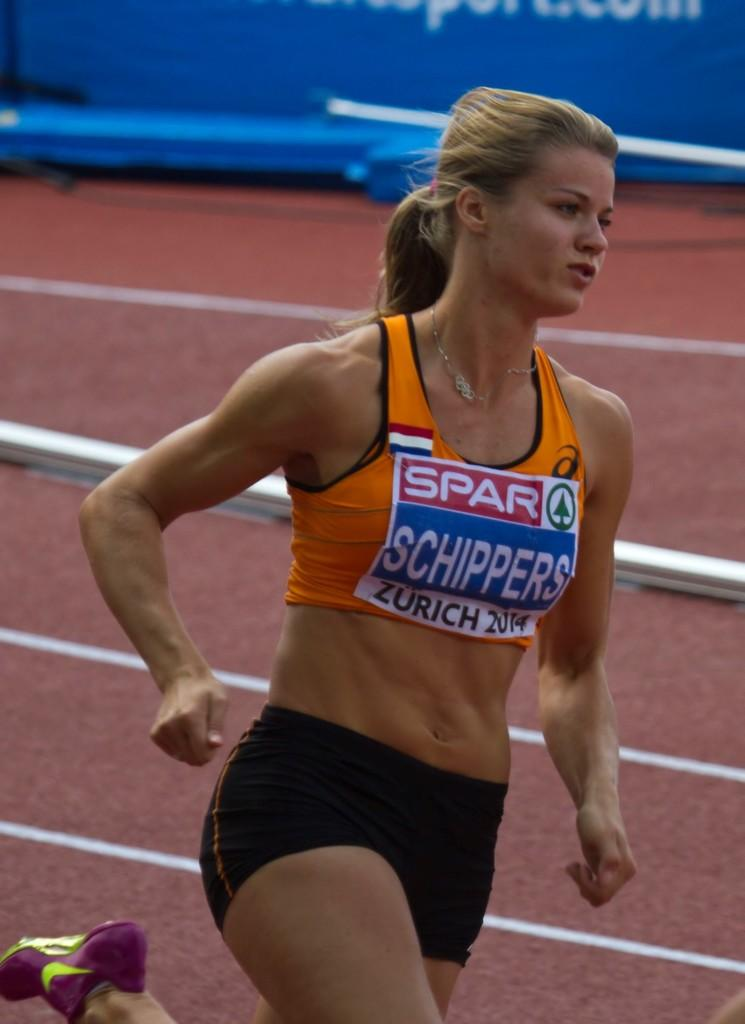Provide a one-sentence caption for the provided image. The city of Zurich is visible on an athlete's ID label. 